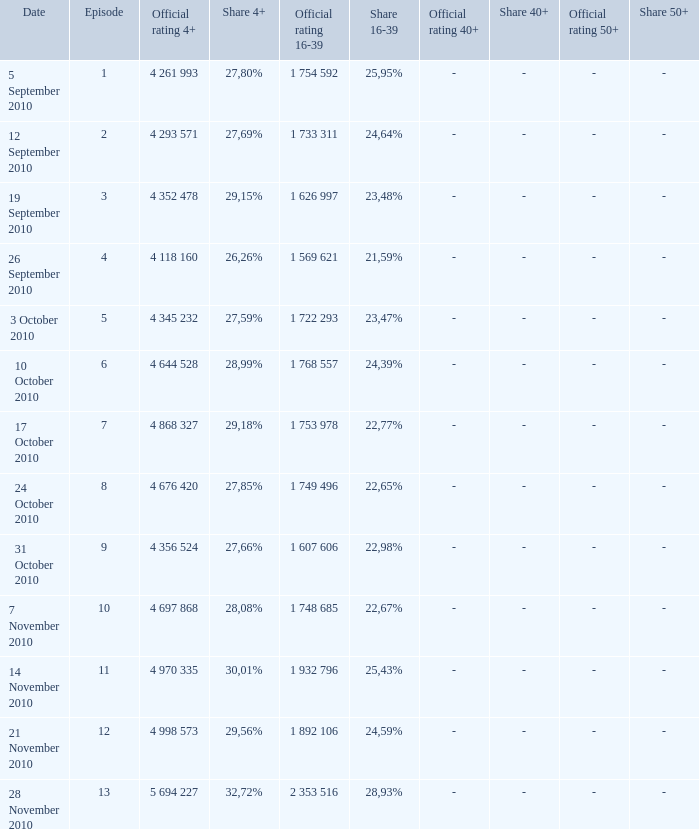What is the official rating 16-39 for the episode with  a 16-39 share of 22,77%? 1 753 978. 